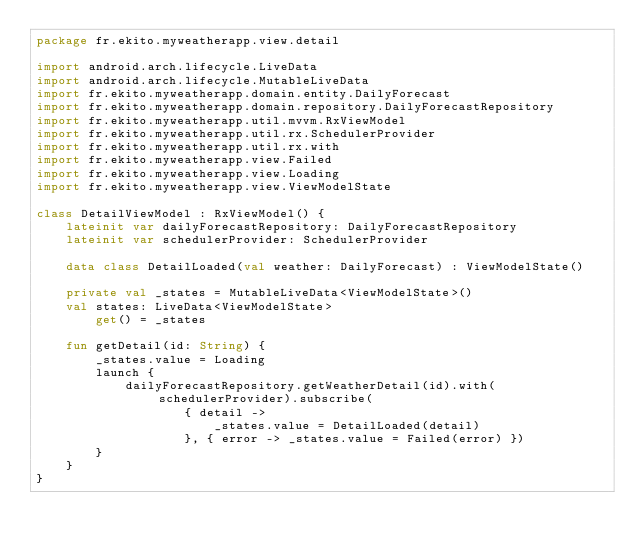Convert code to text. <code><loc_0><loc_0><loc_500><loc_500><_Kotlin_>package fr.ekito.myweatherapp.view.detail

import android.arch.lifecycle.LiveData
import android.arch.lifecycle.MutableLiveData
import fr.ekito.myweatherapp.domain.entity.DailyForecast
import fr.ekito.myweatherapp.domain.repository.DailyForecastRepository
import fr.ekito.myweatherapp.util.mvvm.RxViewModel
import fr.ekito.myweatherapp.util.rx.SchedulerProvider
import fr.ekito.myweatherapp.util.rx.with
import fr.ekito.myweatherapp.view.Failed
import fr.ekito.myweatherapp.view.Loading
import fr.ekito.myweatherapp.view.ViewModelState

class DetailViewModel : RxViewModel() {
    lateinit var dailyForecastRepository: DailyForecastRepository
    lateinit var schedulerProvider: SchedulerProvider

    data class DetailLoaded(val weather: DailyForecast) : ViewModelState()

    private val _states = MutableLiveData<ViewModelState>()
    val states: LiveData<ViewModelState>
        get() = _states

    fun getDetail(id: String) {
        _states.value = Loading
        launch {
            dailyForecastRepository.getWeatherDetail(id).with(schedulerProvider).subscribe(
                    { detail ->
                        _states.value = DetailLoaded(detail)
                    }, { error -> _states.value = Failed(error) })
        }
    }
}</code> 